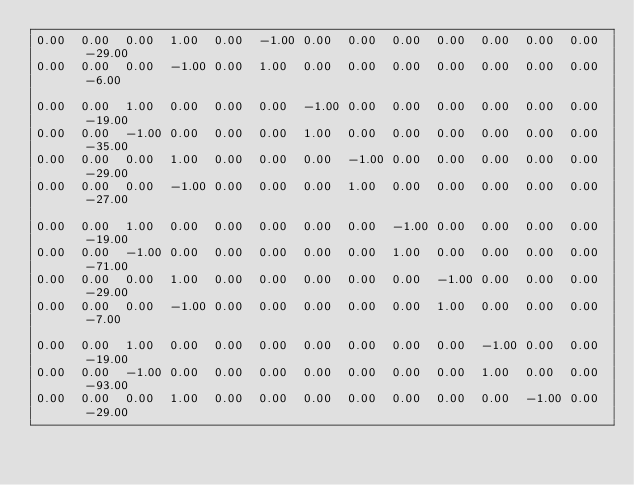<code> <loc_0><loc_0><loc_500><loc_500><_Matlab_>0.00	0.00	0.00	1.00	0.00	-1.00	0.00	0.00	0.00	0.00	0.00	0.00	0.00	-29.00
0.00	0.00	0.00	-1.00	0.00	1.00	0.00	0.00	0.00	0.00	0.00	0.00	0.00	-6.00

0.00	0.00	1.00	0.00	0.00	0.00	-1.00	0.00	0.00	0.00	0.00	0.00	0.00	-19.00
0.00	0.00	-1.00	0.00	0.00	0.00	1.00	0.00	0.00	0.00	0.00	0.00	0.00	-35.00
0.00	0.00	0.00	1.00	0.00	0.00	0.00	-1.00	0.00	0.00	0.00	0.00	0.00	-29.00
0.00	0.00	0.00	-1.00	0.00	0.00	0.00	1.00	0.00	0.00	0.00	0.00	0.00	-27.00

0.00	0.00	1.00	0.00	0.00	0.00	0.00	0.00	-1.00	0.00	0.00	0.00	0.00	-19.00
0.00	0.00	-1.00	0.00	0.00	0.00	0.00	0.00	1.00	0.00	0.00	0.00	0.00	-71.00
0.00	0.00	0.00	1.00	0.00	0.00	0.00	0.00	0.00	-1.00	0.00	0.00	0.00	-29.00
0.00	0.00	0.00	-1.00	0.00	0.00	0.00	0.00	0.00	1.00	0.00	0.00	0.00	-7.00

0.00	0.00	1.00	0.00	0.00	0.00	0.00	0.00	0.00	0.00	-1.00	0.00	0.00	-19.00
0.00	0.00	-1.00	0.00	0.00	0.00	0.00	0.00	0.00	0.00	1.00	0.00	0.00	-93.00
0.00	0.00	0.00	1.00	0.00	0.00	0.00	0.00	0.00	0.00	0.00	-1.00	0.00	-29.00</code> 